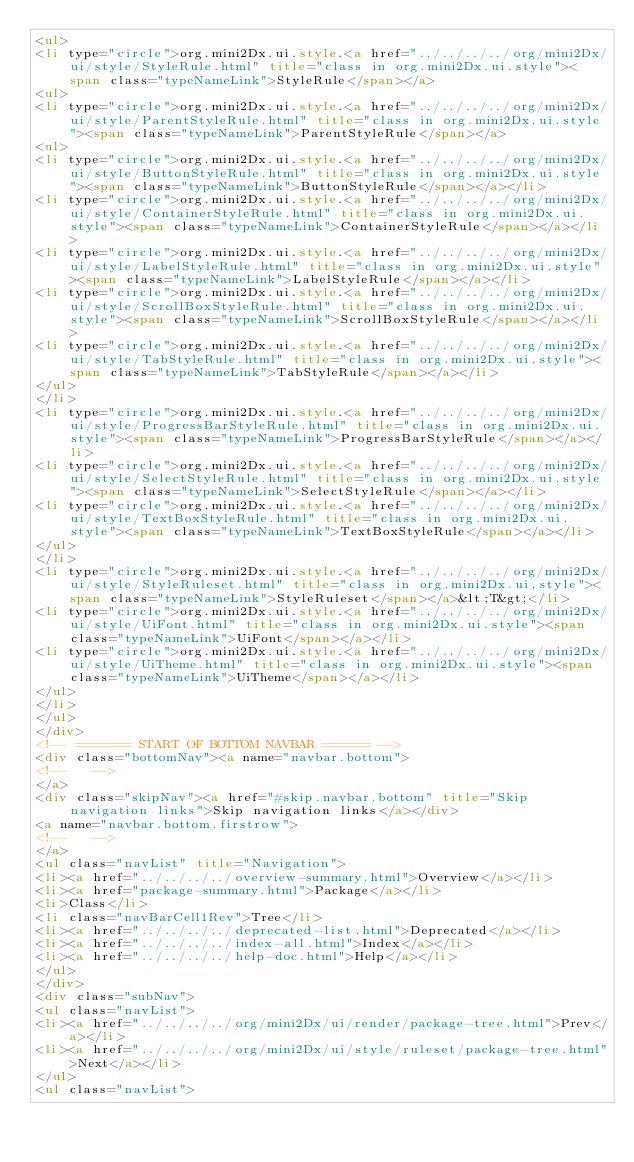Convert code to text. <code><loc_0><loc_0><loc_500><loc_500><_HTML_><ul>
<li type="circle">org.mini2Dx.ui.style.<a href="../../../../org/mini2Dx/ui/style/StyleRule.html" title="class in org.mini2Dx.ui.style"><span class="typeNameLink">StyleRule</span></a>
<ul>
<li type="circle">org.mini2Dx.ui.style.<a href="../../../../org/mini2Dx/ui/style/ParentStyleRule.html" title="class in org.mini2Dx.ui.style"><span class="typeNameLink">ParentStyleRule</span></a>
<ul>
<li type="circle">org.mini2Dx.ui.style.<a href="../../../../org/mini2Dx/ui/style/ButtonStyleRule.html" title="class in org.mini2Dx.ui.style"><span class="typeNameLink">ButtonStyleRule</span></a></li>
<li type="circle">org.mini2Dx.ui.style.<a href="../../../../org/mini2Dx/ui/style/ContainerStyleRule.html" title="class in org.mini2Dx.ui.style"><span class="typeNameLink">ContainerStyleRule</span></a></li>
<li type="circle">org.mini2Dx.ui.style.<a href="../../../../org/mini2Dx/ui/style/LabelStyleRule.html" title="class in org.mini2Dx.ui.style"><span class="typeNameLink">LabelStyleRule</span></a></li>
<li type="circle">org.mini2Dx.ui.style.<a href="../../../../org/mini2Dx/ui/style/ScrollBoxStyleRule.html" title="class in org.mini2Dx.ui.style"><span class="typeNameLink">ScrollBoxStyleRule</span></a></li>
<li type="circle">org.mini2Dx.ui.style.<a href="../../../../org/mini2Dx/ui/style/TabStyleRule.html" title="class in org.mini2Dx.ui.style"><span class="typeNameLink">TabStyleRule</span></a></li>
</ul>
</li>
<li type="circle">org.mini2Dx.ui.style.<a href="../../../../org/mini2Dx/ui/style/ProgressBarStyleRule.html" title="class in org.mini2Dx.ui.style"><span class="typeNameLink">ProgressBarStyleRule</span></a></li>
<li type="circle">org.mini2Dx.ui.style.<a href="../../../../org/mini2Dx/ui/style/SelectStyleRule.html" title="class in org.mini2Dx.ui.style"><span class="typeNameLink">SelectStyleRule</span></a></li>
<li type="circle">org.mini2Dx.ui.style.<a href="../../../../org/mini2Dx/ui/style/TextBoxStyleRule.html" title="class in org.mini2Dx.ui.style"><span class="typeNameLink">TextBoxStyleRule</span></a></li>
</ul>
</li>
<li type="circle">org.mini2Dx.ui.style.<a href="../../../../org/mini2Dx/ui/style/StyleRuleset.html" title="class in org.mini2Dx.ui.style"><span class="typeNameLink">StyleRuleset</span></a>&lt;T&gt;</li>
<li type="circle">org.mini2Dx.ui.style.<a href="../../../../org/mini2Dx/ui/style/UiFont.html" title="class in org.mini2Dx.ui.style"><span class="typeNameLink">UiFont</span></a></li>
<li type="circle">org.mini2Dx.ui.style.<a href="../../../../org/mini2Dx/ui/style/UiTheme.html" title="class in org.mini2Dx.ui.style"><span class="typeNameLink">UiTheme</span></a></li>
</ul>
</li>
</ul>
</div>
<!-- ======= START OF BOTTOM NAVBAR ====== -->
<div class="bottomNav"><a name="navbar.bottom">
<!--   -->
</a>
<div class="skipNav"><a href="#skip.navbar.bottom" title="Skip navigation links">Skip navigation links</a></div>
<a name="navbar.bottom.firstrow">
<!--   -->
</a>
<ul class="navList" title="Navigation">
<li><a href="../../../../overview-summary.html">Overview</a></li>
<li><a href="package-summary.html">Package</a></li>
<li>Class</li>
<li class="navBarCell1Rev">Tree</li>
<li><a href="../../../../deprecated-list.html">Deprecated</a></li>
<li><a href="../../../../index-all.html">Index</a></li>
<li><a href="../../../../help-doc.html">Help</a></li>
</ul>
</div>
<div class="subNav">
<ul class="navList">
<li><a href="../../../../org/mini2Dx/ui/render/package-tree.html">Prev</a></li>
<li><a href="../../../../org/mini2Dx/ui/style/ruleset/package-tree.html">Next</a></li>
</ul>
<ul class="navList"></code> 